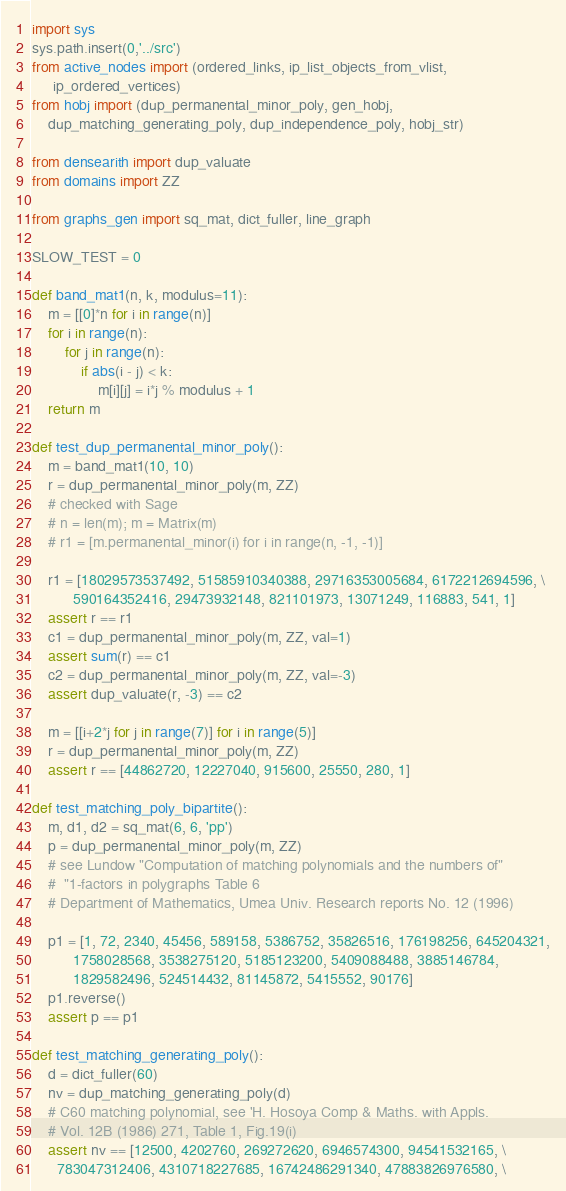Convert code to text. <code><loc_0><loc_0><loc_500><loc_500><_Python_>import sys
sys.path.insert(0,'../src')
from active_nodes import (ordered_links, ip_list_objects_from_vlist,
     ip_ordered_vertices)
from hobj import (dup_permanental_minor_poly, gen_hobj,
    dup_matching_generating_poly, dup_independence_poly, hobj_str)

from densearith import dup_valuate
from domains import ZZ

from graphs_gen import sq_mat, dict_fuller, line_graph

SLOW_TEST = 0

def band_mat1(n, k, modulus=11):
    m = [[0]*n for i in range(n)]
    for i in range(n):
        for j in range(n):
            if abs(i - j) < k:
                m[i][j] = i*j % modulus + 1
    return m

def test_dup_permanental_minor_poly():
    m = band_mat1(10, 10)
    r = dup_permanental_minor_poly(m, ZZ)
    # checked with Sage
    # n = len(m); m = Matrix(m)
    # r1 = [m.permanental_minor(i) for i in range(n, -1, -1)]

    r1 = [18029573537492, 51585910340388, 29716353005684, 6172212694596, \
          590164352416, 29473932148, 821101973, 13071249, 116883, 541, 1]
    assert r == r1
    c1 = dup_permanental_minor_poly(m, ZZ, val=1)
    assert sum(r) == c1
    c2 = dup_permanental_minor_poly(m, ZZ, val=-3)
    assert dup_valuate(r, -3) == c2

    m = [[i+2*j for j in range(7)] for i in range(5)]
    r = dup_permanental_minor_poly(m, ZZ)
    assert r == [44862720, 12227040, 915600, 25550, 280, 1]

def test_matching_poly_bipartite():
    m, d1, d2 = sq_mat(6, 6, 'pp')
    p = dup_permanental_minor_poly(m, ZZ)
    # see Lundow "Computation of matching polynomials and the numbers of"
    #  "1-factors in polygraphs Table 6
    # Department of Mathematics, Umea Univ. Research reports No. 12 (1996)

    p1 = [1, 72, 2340, 45456, 589158, 5386752, 35826516, 176198256, 645204321,
          1758028568, 3538275120, 5185123200, 5409088488, 3885146784,
          1829582496, 524514432, 81145872, 5415552, 90176]
    p1.reverse()
    assert p == p1

def test_matching_generating_poly():
    d = dict_fuller(60)
    nv = dup_matching_generating_poly(d)
    # C60 matching polynomial, see 'H. Hosoya Comp & Maths. with Appls.
    # Vol. 12B (1986) 271, Table 1, Fig.19(i)
    assert nv == [12500, 4202760, 269272620, 6946574300, 94541532165, \
      783047312406, 4310718227685, 16742486291340, 47883826976580, \</code> 